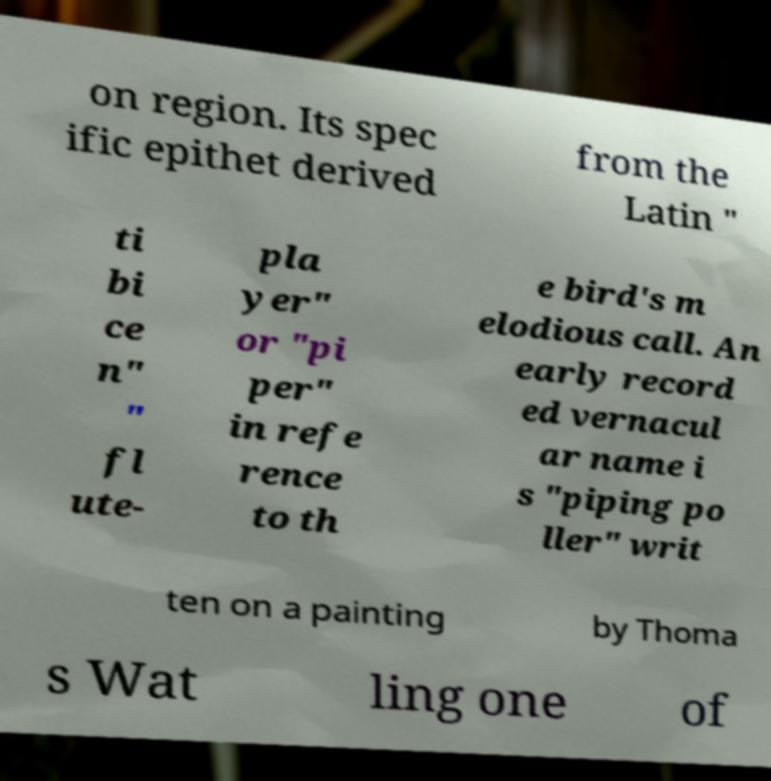I need the written content from this picture converted into text. Can you do that? on region. Its spec ific epithet derived from the Latin " ti bi ce n" " fl ute- pla yer" or "pi per" in refe rence to th e bird's m elodious call. An early record ed vernacul ar name i s "piping po ller" writ ten on a painting by Thoma s Wat ling one of 